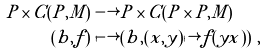Convert formula to latex. <formula><loc_0><loc_0><loc_500><loc_500>P \times C ( P , M ) & \longrightarrow P \times C ( P \times P , M ) \\ ( b , f ) & \longmapsto ( b , ( x , y ) \mapsto f ( y x ) ) \ ,</formula> 